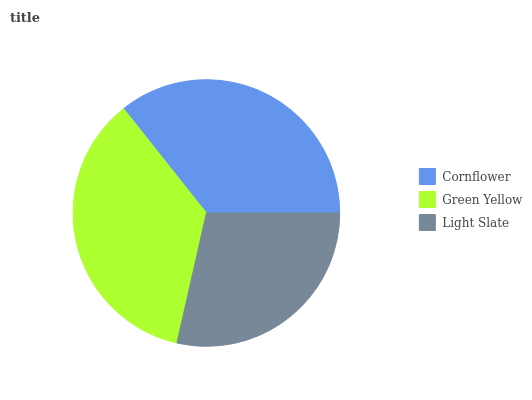Is Light Slate the minimum?
Answer yes or no. Yes. Is Green Yellow the maximum?
Answer yes or no. Yes. Is Green Yellow the minimum?
Answer yes or no. No. Is Light Slate the maximum?
Answer yes or no. No. Is Green Yellow greater than Light Slate?
Answer yes or no. Yes. Is Light Slate less than Green Yellow?
Answer yes or no. Yes. Is Light Slate greater than Green Yellow?
Answer yes or no. No. Is Green Yellow less than Light Slate?
Answer yes or no. No. Is Cornflower the high median?
Answer yes or no. Yes. Is Cornflower the low median?
Answer yes or no. Yes. Is Green Yellow the high median?
Answer yes or no. No. Is Green Yellow the low median?
Answer yes or no. No. 